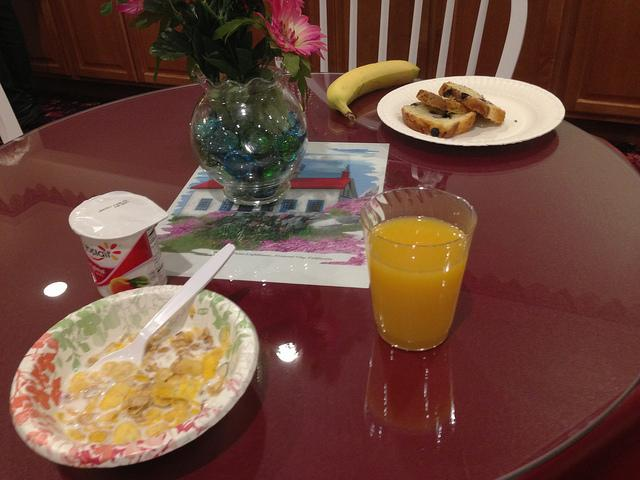What fruit used to prepare items here is darkest? Please explain your reasoning. blueberries. It looks like blueberries in some slices of bread. 